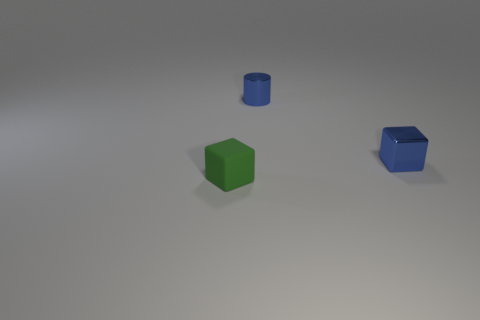Is there any other thing that has the same material as the green block?
Provide a short and direct response. No. Is the size of the cube on the right side of the green rubber object the same as the shiny cylinder?
Provide a succinct answer. Yes. There is a thing that is to the left of the shiny cube and to the right of the green block; what shape is it?
Ensure brevity in your answer.  Cylinder. There is a metallic cylinder; are there any small shiny cylinders left of it?
Ensure brevity in your answer.  No. Is there any other thing that is the same shape as the small green thing?
Your response must be concise. Yes. Are there the same number of tiny blue objects that are behind the blue cylinder and small blue metal blocks that are behind the matte object?
Provide a succinct answer. No. What number of other things are made of the same material as the green cube?
Ensure brevity in your answer.  0. What number of tiny things are matte things or gray shiny balls?
Your response must be concise. 1. Are there an equal number of tiny cubes behind the blue cylinder and blue cylinders?
Your answer should be compact. No. Are there any blue metallic objects in front of the small cube that is on the right side of the small rubber block?
Your answer should be very brief. No. 